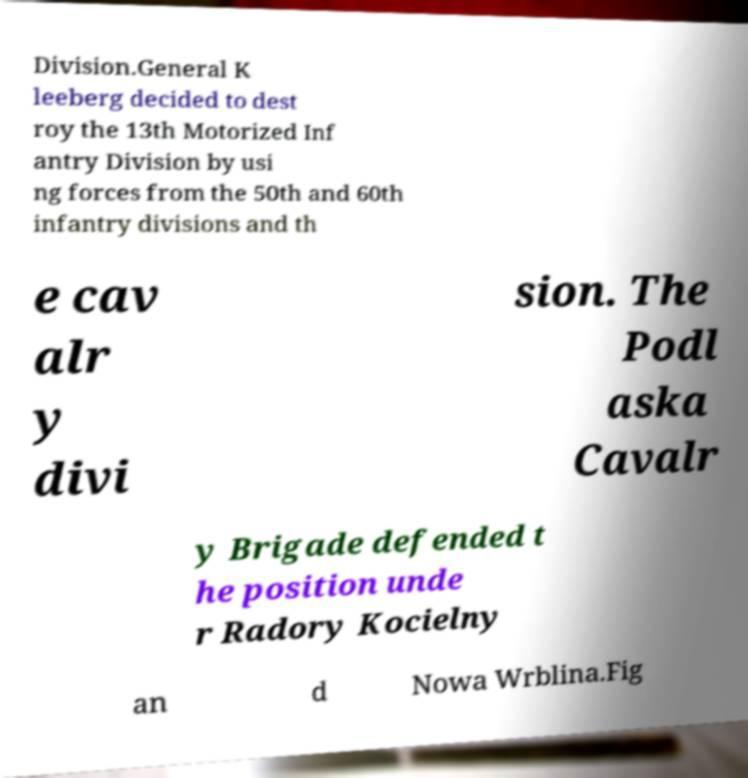Could you extract and type out the text from this image? Division.General K leeberg decided to dest roy the 13th Motorized Inf antry Division by usi ng forces from the 50th and 60th infantry divisions and th e cav alr y divi sion. The Podl aska Cavalr y Brigade defended t he position unde r Radory Kocielny an d Nowa Wrblina.Fig 